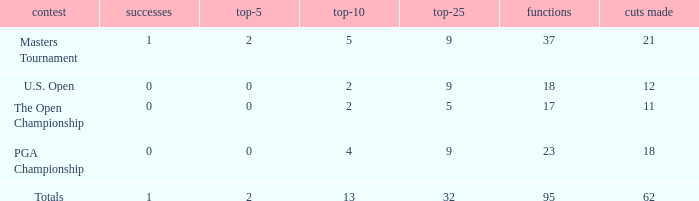What is the average number of cuts made in the Top 25 smaller than 5? None. 